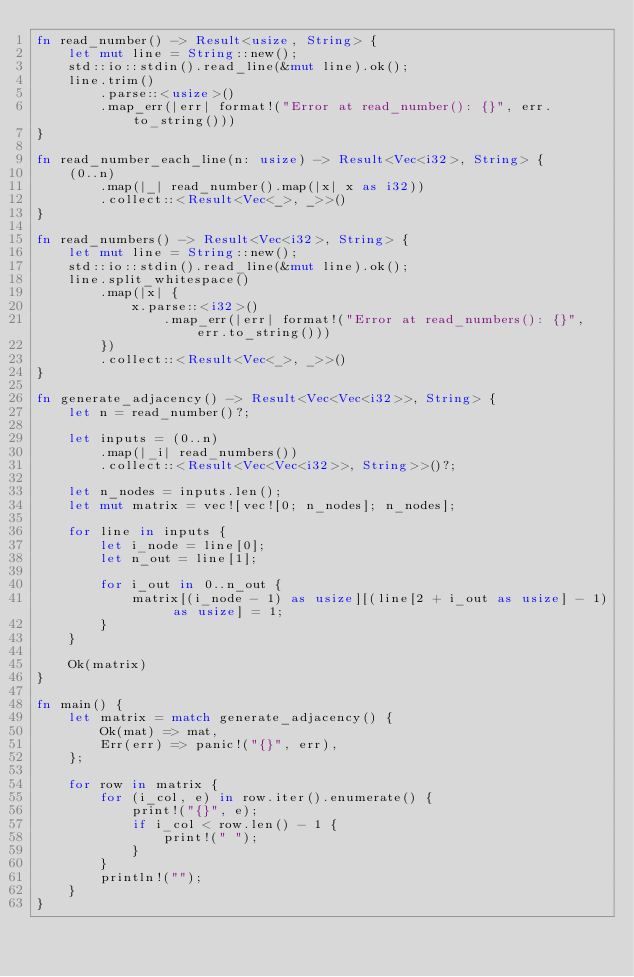<code> <loc_0><loc_0><loc_500><loc_500><_Rust_>fn read_number() -> Result<usize, String> {
    let mut line = String::new();
    std::io::stdin().read_line(&mut line).ok();
    line.trim()
        .parse::<usize>()
        .map_err(|err| format!("Error at read_number(): {}", err.to_string()))
}

fn read_number_each_line(n: usize) -> Result<Vec<i32>, String> {
    (0..n)
        .map(|_| read_number().map(|x| x as i32))
        .collect::<Result<Vec<_>, _>>()
}

fn read_numbers() -> Result<Vec<i32>, String> {
    let mut line = String::new();
    std::io::stdin().read_line(&mut line).ok();
    line.split_whitespace()
        .map(|x| {
            x.parse::<i32>()
                .map_err(|err| format!("Error at read_numbers(): {}", err.to_string()))
        })
        .collect::<Result<Vec<_>, _>>()
}

fn generate_adjacency() -> Result<Vec<Vec<i32>>, String> {
    let n = read_number()?;

    let inputs = (0..n)
        .map(|_i| read_numbers())
        .collect::<Result<Vec<Vec<i32>>, String>>()?;

    let n_nodes = inputs.len();
    let mut matrix = vec![vec![0; n_nodes]; n_nodes];

    for line in inputs {
        let i_node = line[0];
        let n_out = line[1];

        for i_out in 0..n_out {
            matrix[(i_node - 1) as usize][(line[2 + i_out as usize] - 1) as usize] = 1;
        }
    }

    Ok(matrix)
}

fn main() {
    let matrix = match generate_adjacency() {
        Ok(mat) => mat,
        Err(err) => panic!("{}", err),
    };

    for row in matrix {
        for (i_col, e) in row.iter().enumerate() {
            print!("{}", e);
            if i_col < row.len() - 1 {
                print!(" ");
            }
        }
        println!("");
    }
}

</code> 